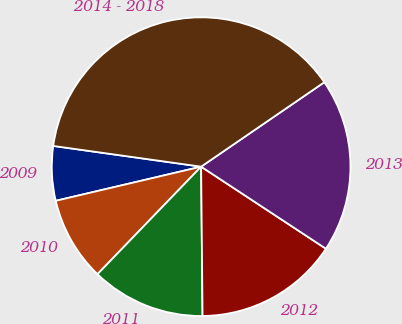Convert chart. <chart><loc_0><loc_0><loc_500><loc_500><pie_chart><fcel>2009<fcel>2010<fcel>2011<fcel>2012<fcel>2013<fcel>2014 - 2018<nl><fcel>5.89%<fcel>9.12%<fcel>12.36%<fcel>15.59%<fcel>18.82%<fcel>38.22%<nl></chart> 